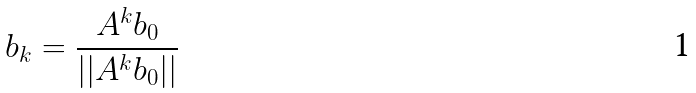<formula> <loc_0><loc_0><loc_500><loc_500>b _ { k } = \frac { A ^ { k } b _ { 0 } } { | | A ^ { k } b _ { 0 } | | }</formula> 